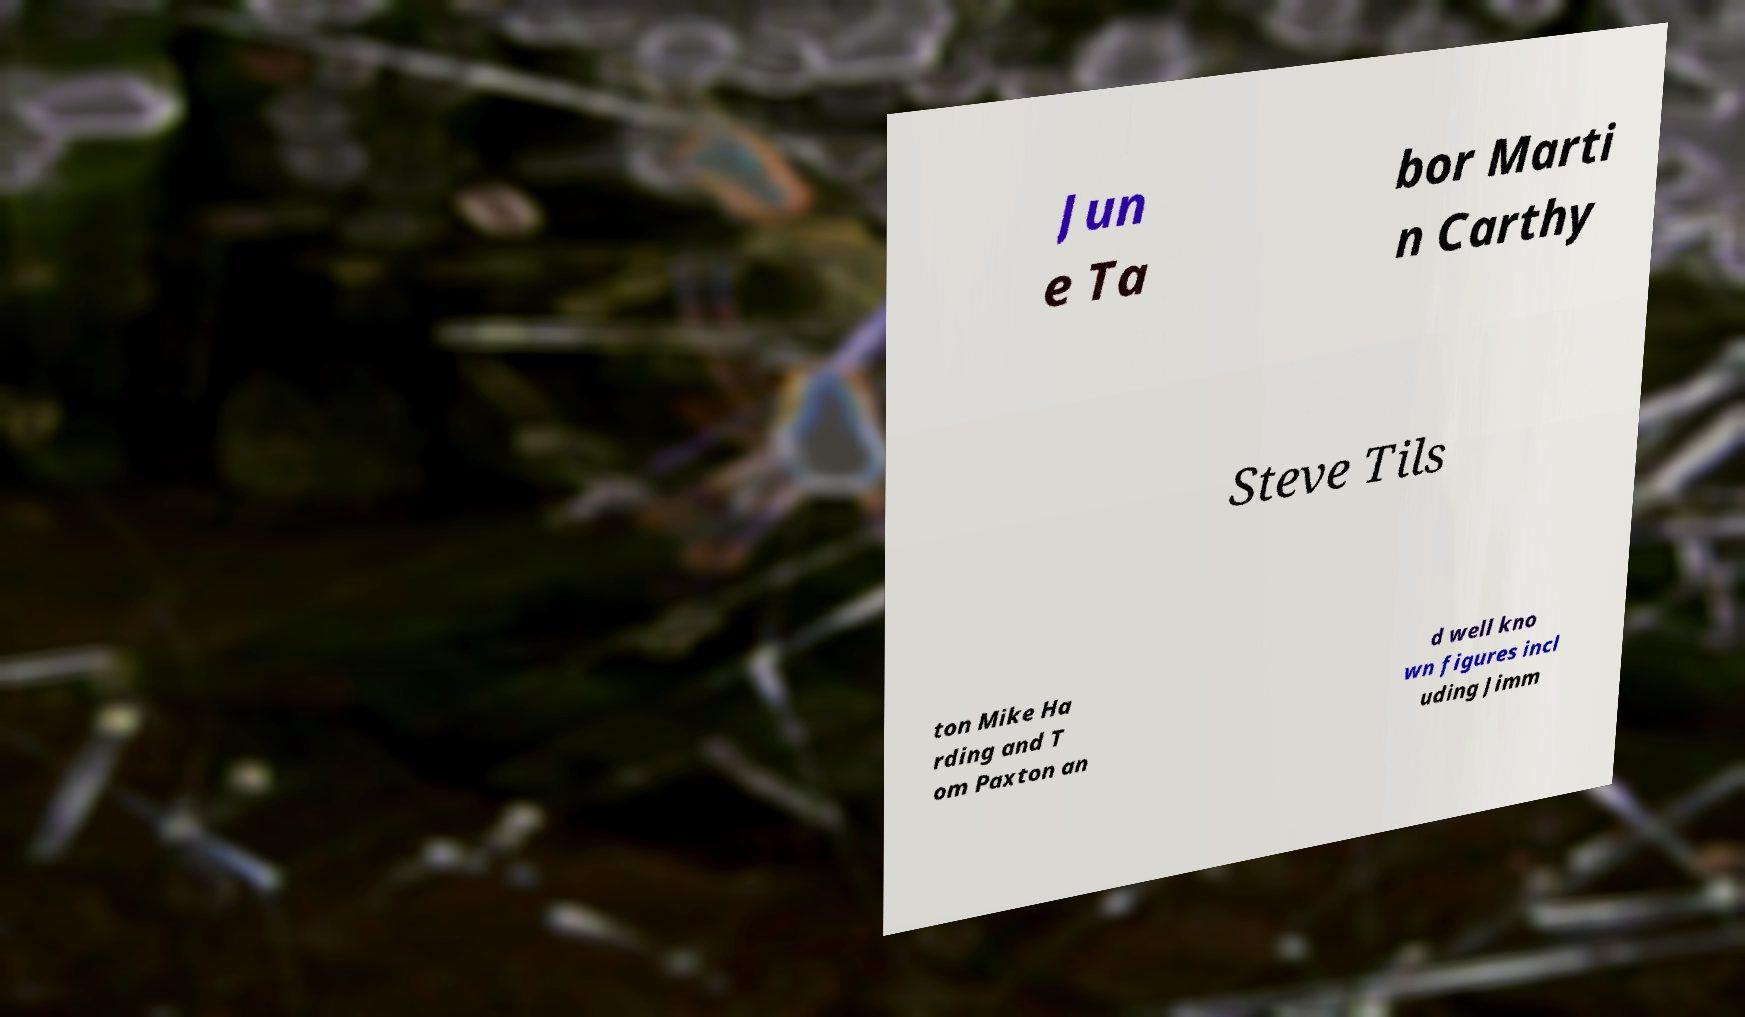For documentation purposes, I need the text within this image transcribed. Could you provide that? Jun e Ta bor Marti n Carthy Steve Tils ton Mike Ha rding and T om Paxton an d well kno wn figures incl uding Jimm 